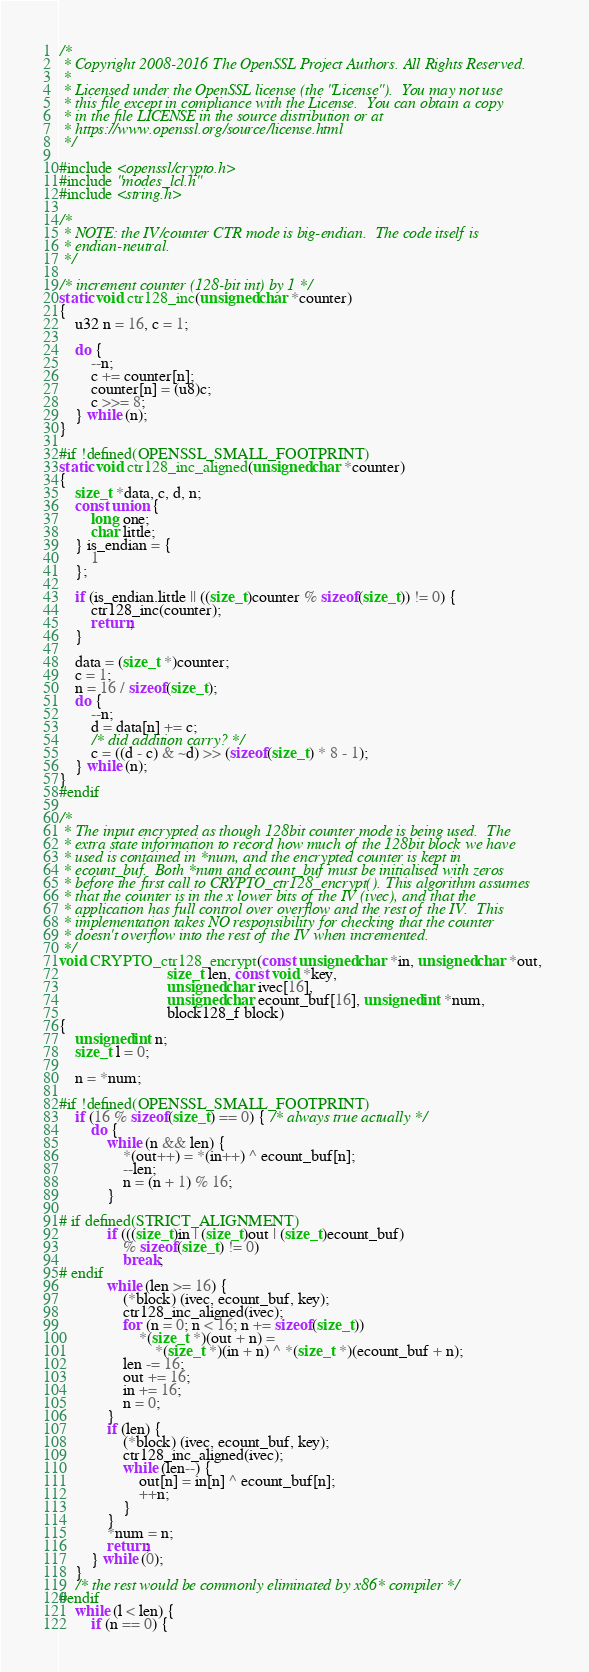Convert code to text. <code><loc_0><loc_0><loc_500><loc_500><_C_>/*
 * Copyright 2008-2016 The OpenSSL Project Authors. All Rights Reserved.
 *
 * Licensed under the OpenSSL license (the "License").  You may not use
 * this file except in compliance with the License.  You can obtain a copy
 * in the file LICENSE in the source distribution or at
 * https://www.openssl.org/source/license.html
 */

#include <openssl/crypto.h>
#include "modes_lcl.h"
#include <string.h>

/*
 * NOTE: the IV/counter CTR mode is big-endian.  The code itself is
 * endian-neutral.
 */

/* increment counter (128-bit int) by 1 */
static void ctr128_inc(unsigned char *counter)
{
    u32 n = 16, c = 1;

    do {
        --n;
        c += counter[n];
        counter[n] = (u8)c;
        c >>= 8;
    } while (n);
}

#if !defined(OPENSSL_SMALL_FOOTPRINT)
static void ctr128_inc_aligned(unsigned char *counter)
{
    size_t *data, c, d, n;
    const union {
        long one;
        char little;
    } is_endian = {
        1
    };

    if (is_endian.little || ((size_t)counter % sizeof(size_t)) != 0) {
        ctr128_inc(counter);
        return;
    }

    data = (size_t *)counter;
    c = 1;
    n = 16 / sizeof(size_t);
    do {
        --n;
        d = data[n] += c;
        /* did addition carry? */
        c = ((d - c) & ~d) >> (sizeof(size_t) * 8 - 1);
    } while (n);
}
#endif

/*
 * The input encrypted as though 128bit counter mode is being used.  The
 * extra state information to record how much of the 128bit block we have
 * used is contained in *num, and the encrypted counter is kept in
 * ecount_buf.  Both *num and ecount_buf must be initialised with zeros
 * before the first call to CRYPTO_ctr128_encrypt(). This algorithm assumes
 * that the counter is in the x lower bits of the IV (ivec), and that the
 * application has full control over overflow and the rest of the IV.  This
 * implementation takes NO responsibility for checking that the counter
 * doesn't overflow into the rest of the IV when incremented.
 */
void CRYPTO_ctr128_encrypt(const unsigned char *in, unsigned char *out,
                           size_t len, const void *key,
                           unsigned char ivec[16],
                           unsigned char ecount_buf[16], unsigned int *num,
                           block128_f block)
{
    unsigned int n;
    size_t l = 0;

    n = *num;

#if !defined(OPENSSL_SMALL_FOOTPRINT)
    if (16 % sizeof(size_t) == 0) { /* always true actually */
        do {
            while (n && len) {
                *(out++) = *(in++) ^ ecount_buf[n];
                --len;
                n = (n + 1) % 16;
            }

# if defined(STRICT_ALIGNMENT)
            if (((size_t)in | (size_t)out | (size_t)ecount_buf)
                % sizeof(size_t) != 0)
                break;
# endif
            while (len >= 16) {
                (*block) (ivec, ecount_buf, key);
                ctr128_inc_aligned(ivec);
                for (n = 0; n < 16; n += sizeof(size_t))
                    *(size_t *)(out + n) =
                        *(size_t *)(in + n) ^ *(size_t *)(ecount_buf + n);
                len -= 16;
                out += 16;
                in += 16;
                n = 0;
            }
            if (len) {
                (*block) (ivec, ecount_buf, key);
                ctr128_inc_aligned(ivec);
                while (len--) {
                    out[n] = in[n] ^ ecount_buf[n];
                    ++n;
                }
            }
            *num = n;
            return;
        } while (0);
    }
    /* the rest would be commonly eliminated by x86* compiler */
#endif
    while (l < len) {
        if (n == 0) {</code> 